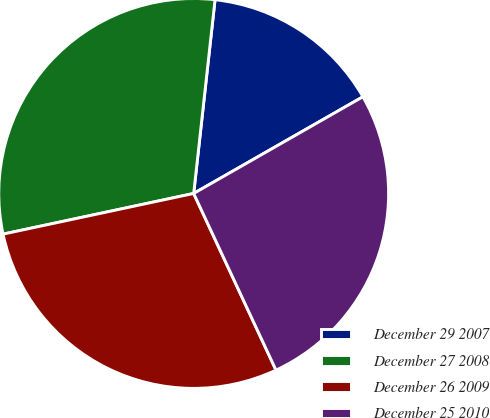<chart> <loc_0><loc_0><loc_500><loc_500><pie_chart><fcel>December 29 2007<fcel>December 27 2008<fcel>December 26 2009<fcel>December 25 2010<nl><fcel>14.99%<fcel>30.09%<fcel>28.59%<fcel>26.32%<nl></chart> 